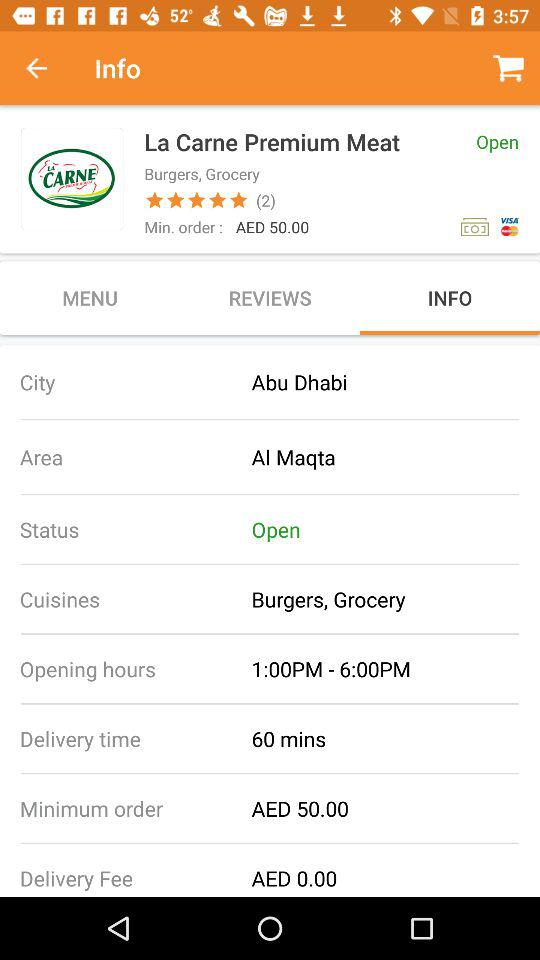What are the restaurant's hours of operation? The restaurant's hours of operation are from 1:00 PM to 6:00 PM. 